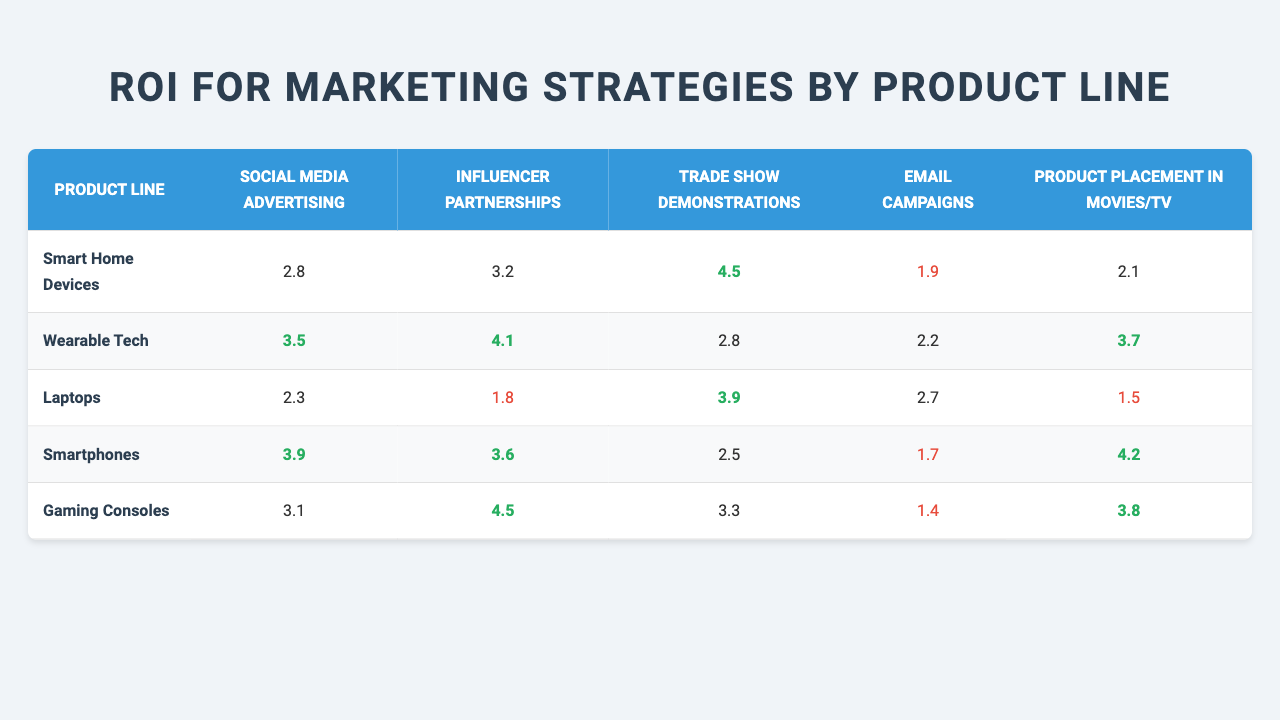What is the ROI for Social Media Advertising for Wearable Tech? According to the table, the ROI for Social Media Advertising for Wearable Tech is listed directly as 3.5.
Answer: 3.5 Which marketing strategy has the highest ROI for Gaming Consoles? By looking at the ROI values for Gaming Consoles, the highest value is 4.5, which corresponds to Influencer Partnerships.
Answer: Influencer Partnerships What is the lowest ROI for Email Campaigns across all product lines? Scanning through the table, the lowest ROI for Email Campaigns is 1.4, which is for Gaming Consoles.
Answer: 1.4 Which product line shows the highest customer satisfaction score? Referring to the customer satisfaction scores, Gaming Consoles has the highest score of 4.7.
Answer: Gaming Consoles What is the average ROI for Trade Show Demonstrations across all product lines? First, take the ROI values for Trade Show Demonstrations: 4.5, 2.8, 3.9, 2.5, and 3.3. The sum is 16.0, and there are 5 product lines, so the average is 16.0 / 5 = 3.2.
Answer: 3.2 Is the ROI for Product Placement in Movies/TV lower for Laptops compared to Wearable Tech? The ROI for Laptops is 1.5 and for Wearable Tech is 3.7. Since 1.5 is less than 3.7, the statement is true.
Answer: Yes Which product line has the highest ROI for Email Campaigns, and what is that value? Looking at the Email Campaigns column, the values are: 1.9, 2.2, 2.7, 1.7, and 1.4. The highest value is 2.7 for Laptops.
Answer: Laptops, 2.7 If we consider the top two marketing strategies by ROI for Smartphones, what are they? The top two marketing strategies for Smartphones are Product Placement in Movies/TV with an ROI of 4.2 and Social Media Advertising with an ROI of 3.9.
Answer: Product Placement in Movies/TV (4.2), Social Media Advertising (3.9) In terms of ROI, how does the performance of Influencer Partnerships for Smart Home Devices compare to that of Wearable Tech? The ROI for Influencer Partnerships in Smart Home Devices is 3.2, while for Wearable Tech, it is 4.1. Since 3.2 is less than 4.1, Smart Home Devices perform worse.
Answer: Smart Home Devices perform worse What is the difference in ROI for Trade Show Demonstrations between Smart Home Devices and Laptops? The ROI for Smart Home Devices is 4.5 and for Laptops is 3.9. The difference is 4.5 - 3.9 = 0.6.
Answer: 0.6 